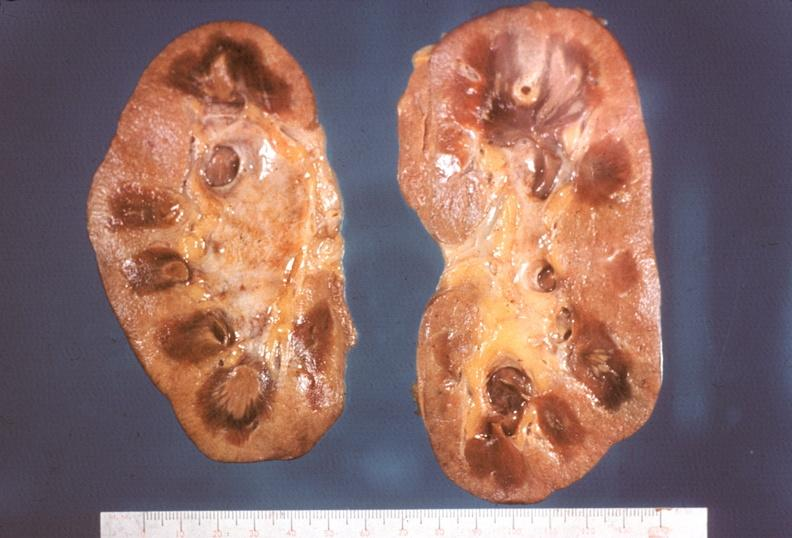s kidney, papillitis, necrotizing?
Answer the question using a single word or phrase. Yes 